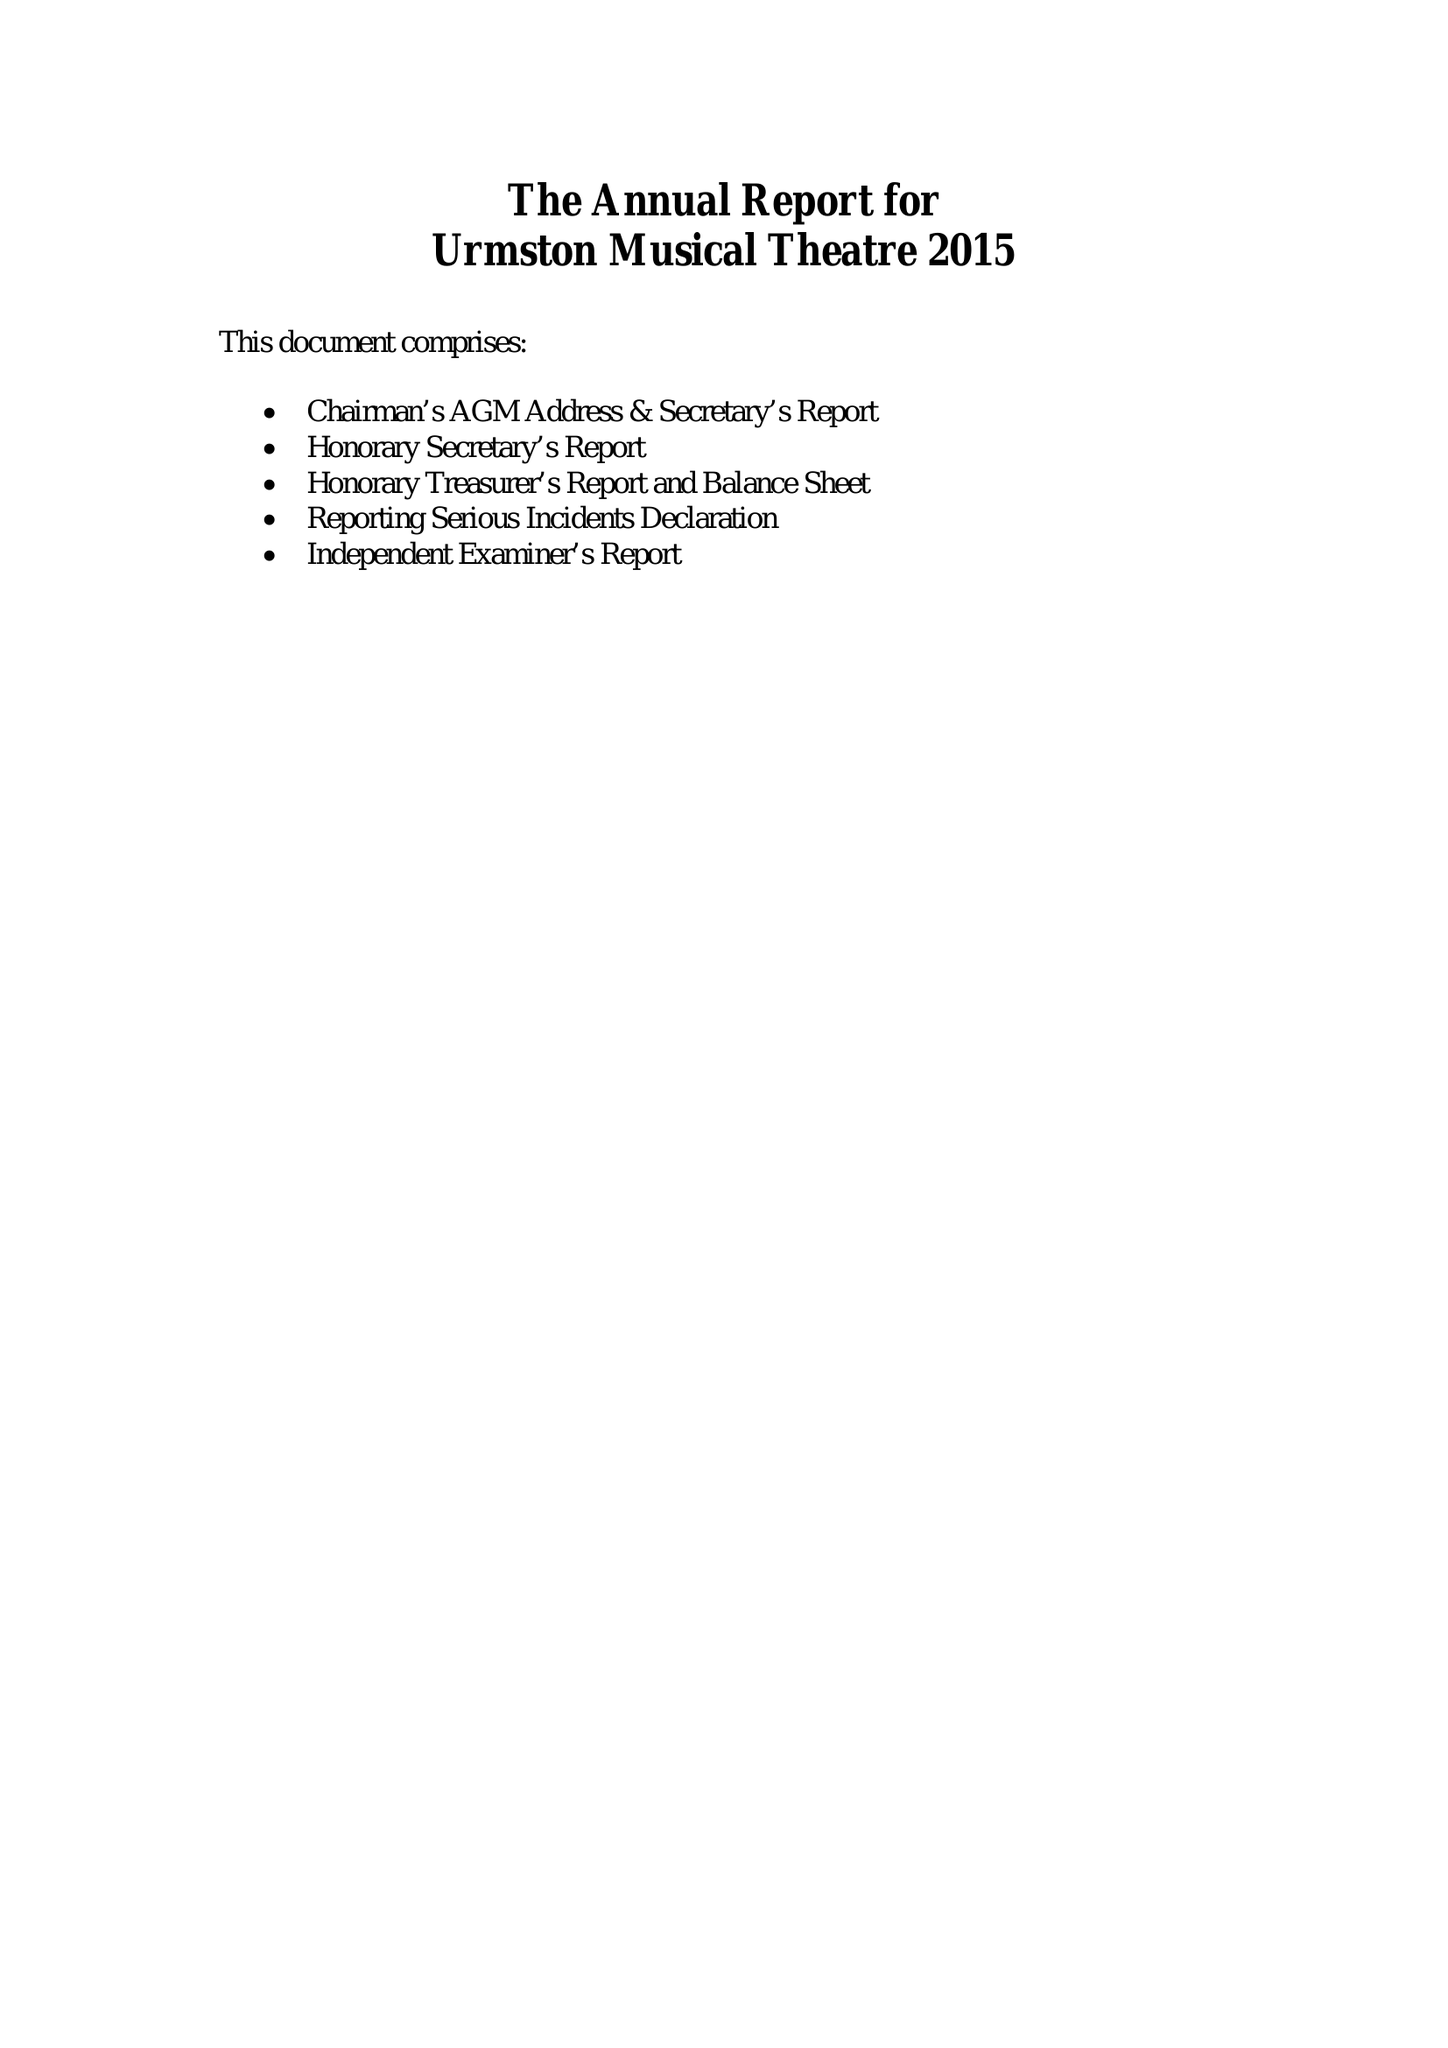What is the value for the address__street_line?
Answer the question using a single word or phrase. 41 PRINCESS ROAD 